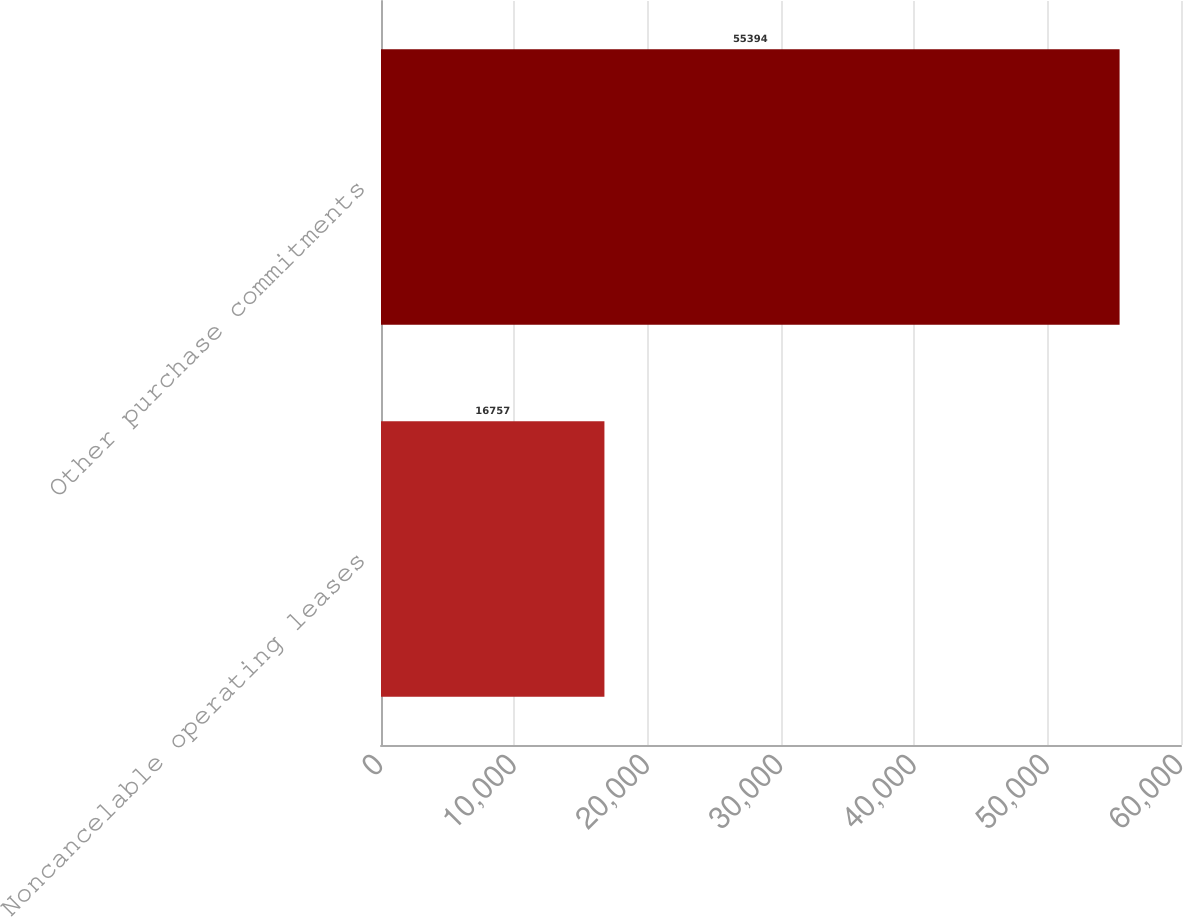<chart> <loc_0><loc_0><loc_500><loc_500><bar_chart><fcel>Noncancelable operating leases<fcel>Other purchase commitments<nl><fcel>16757<fcel>55394<nl></chart> 